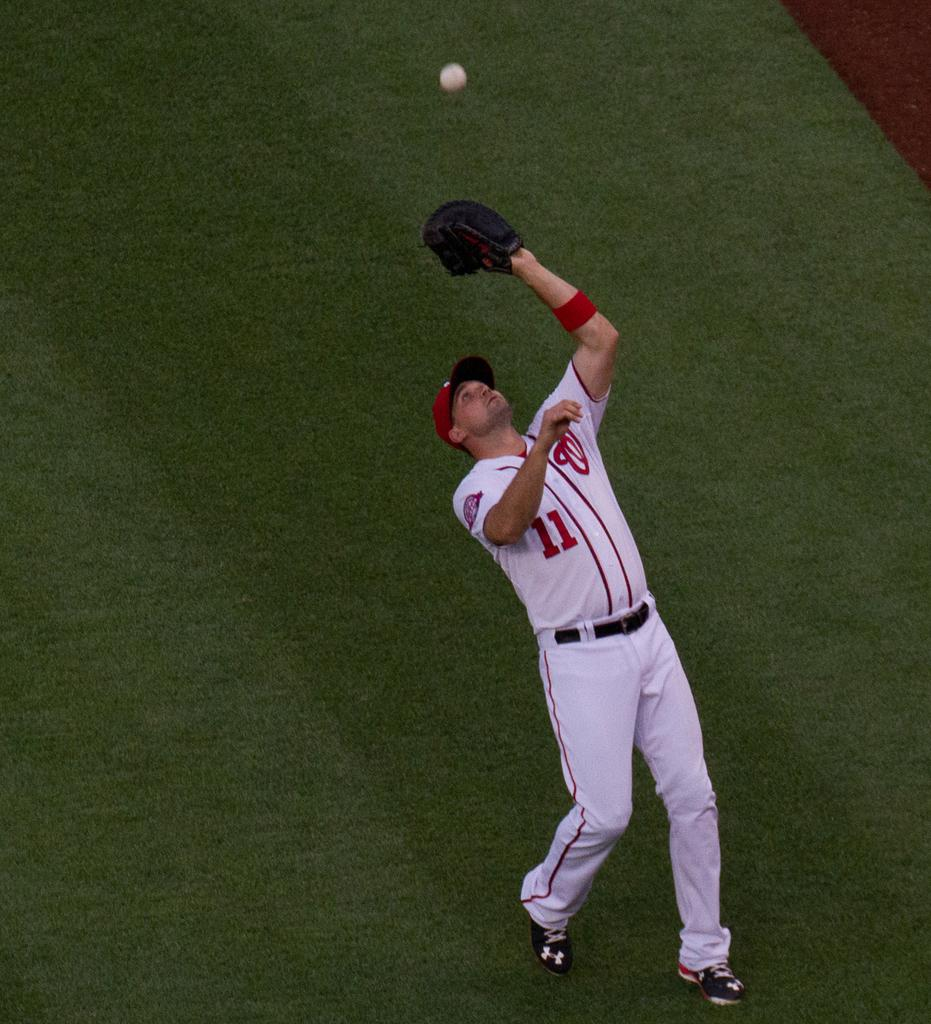<image>
Relay a brief, clear account of the picture shown. Number 11 from the Washington Nationals catches a ball in the outfield. 